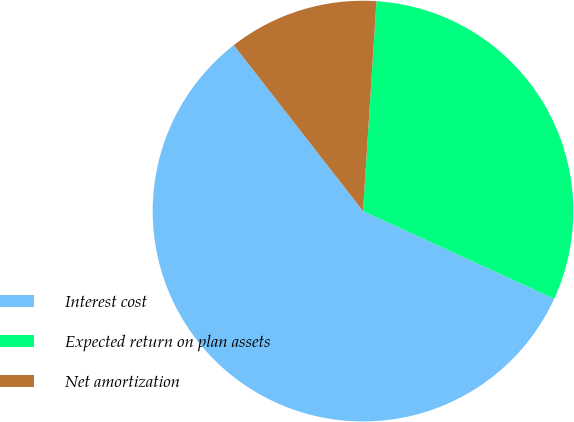Convert chart to OTSL. <chart><loc_0><loc_0><loc_500><loc_500><pie_chart><fcel>Interest cost<fcel>Expected return on plan assets<fcel>Net amortization<nl><fcel>57.62%<fcel>30.83%<fcel>11.55%<nl></chart> 